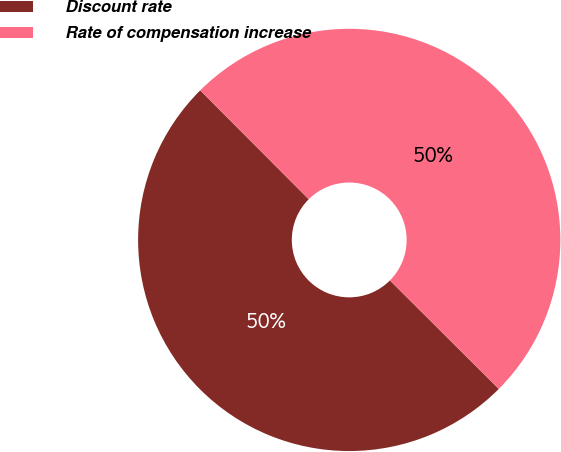Convert chart to OTSL. <chart><loc_0><loc_0><loc_500><loc_500><pie_chart><fcel>Discount rate<fcel>Rate of compensation increase<nl><fcel>50.06%<fcel>49.94%<nl></chart> 